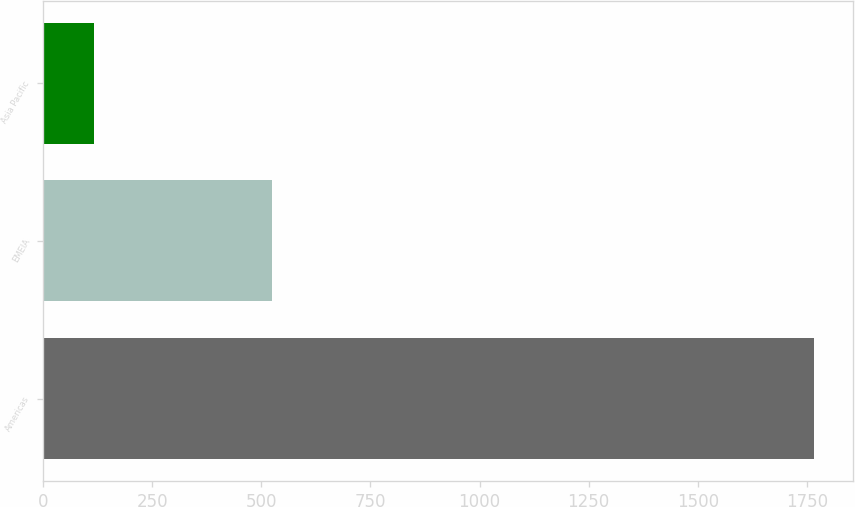Convert chart to OTSL. <chart><loc_0><loc_0><loc_500><loc_500><bar_chart><fcel>Americas<fcel>EMEIA<fcel>Asia Pacific<nl><fcel>1767.5<fcel>523.5<fcel>117.2<nl></chart> 